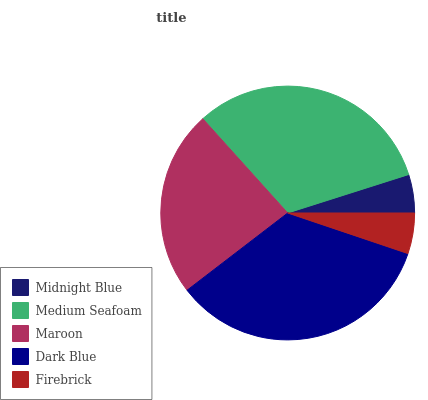Is Midnight Blue the minimum?
Answer yes or no. Yes. Is Dark Blue the maximum?
Answer yes or no. Yes. Is Medium Seafoam the minimum?
Answer yes or no. No. Is Medium Seafoam the maximum?
Answer yes or no. No. Is Medium Seafoam greater than Midnight Blue?
Answer yes or no. Yes. Is Midnight Blue less than Medium Seafoam?
Answer yes or no. Yes. Is Midnight Blue greater than Medium Seafoam?
Answer yes or no. No. Is Medium Seafoam less than Midnight Blue?
Answer yes or no. No. Is Maroon the high median?
Answer yes or no. Yes. Is Maroon the low median?
Answer yes or no. Yes. Is Medium Seafoam the high median?
Answer yes or no. No. Is Midnight Blue the low median?
Answer yes or no. No. 